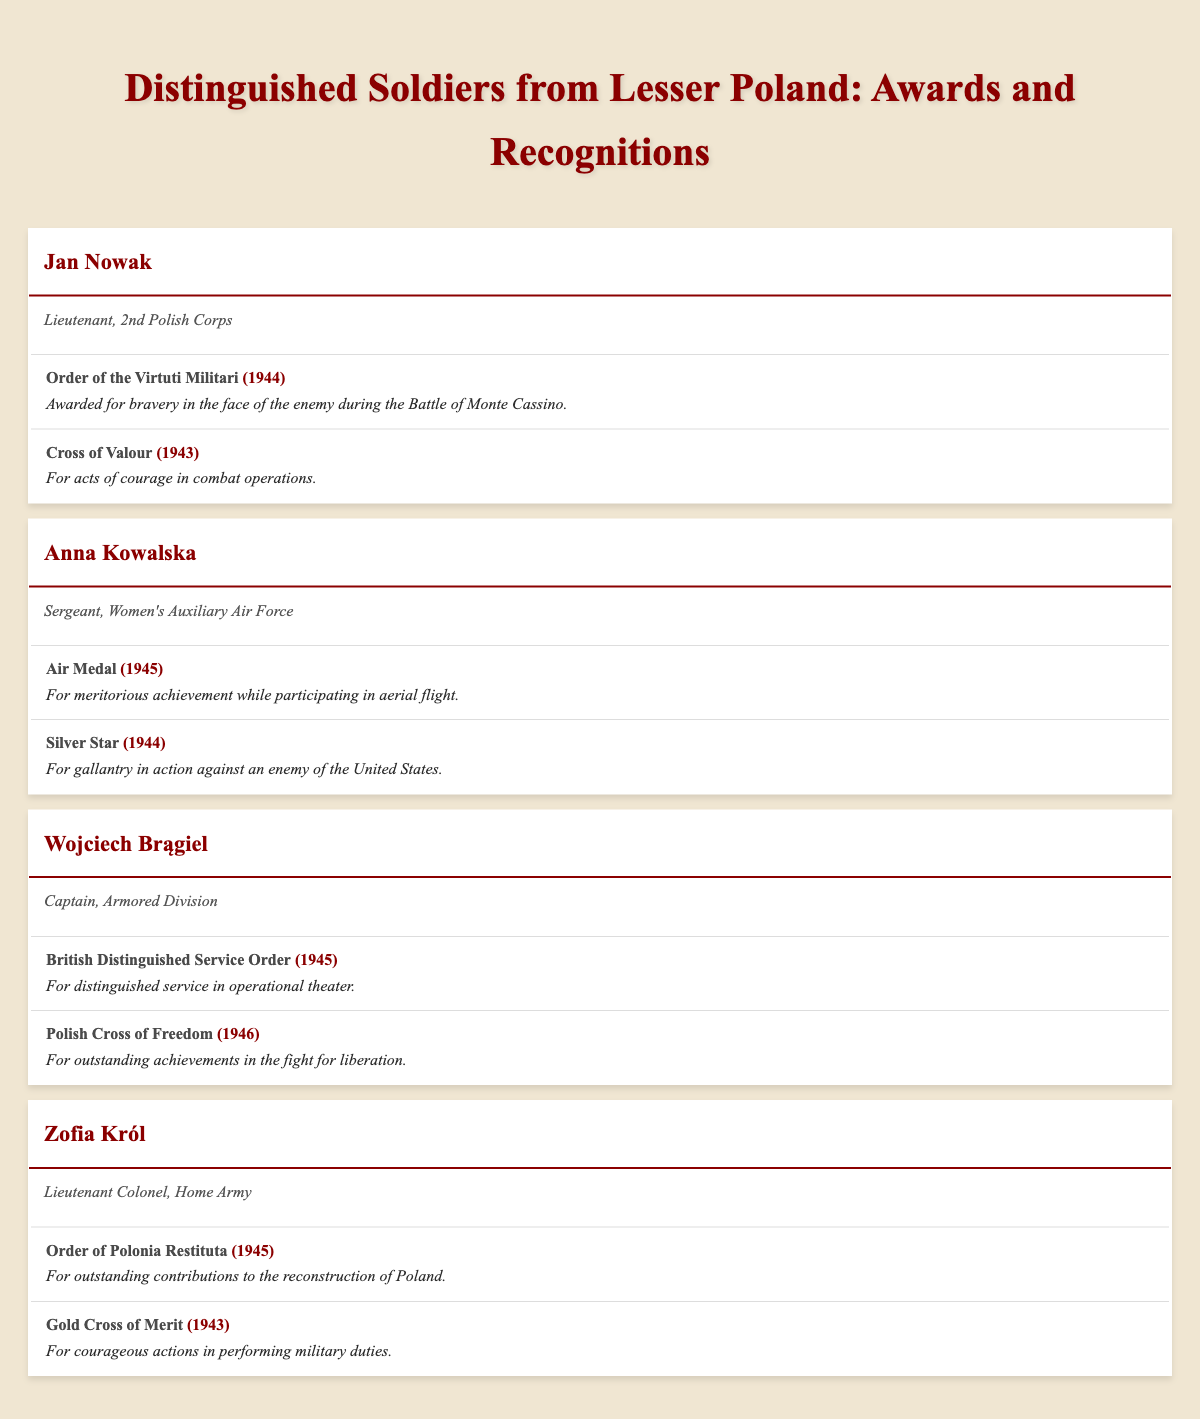What is the rank of Jan Nowak? Jan Nowak is listed in the table under the distinguished soldiers of Lesser Poland, with his rank noted as Lieutenant.
Answer: Lieutenant How many awards did Anna Kowalska receive? Looking at the entry for Anna Kowalska, it shows two awards: the Air Medal and the Silver Star, confirming that she received a total of two awards.
Answer: 2 Who received the Order of the Virtuti Militari? The table indicates that Jan Nowak received the Order of the Virtuti Militari in 1944, specifically for bravery during the Battle of Monte Cassino.
Answer: Jan Nowak Is Zofia Król part of the Home Army? The entry for Zofia Król shows that she served as a Lieutenant Colonel in the Home Army, confirming her association with that unit.
Answer: Yes Which award did Wojciech Brągiel receive in 1946? According to the table, Wojciech Brągiel received the Polish Cross of Freedom in 1946 for his outstanding achievements in the fight for liberation.
Answer: Polish Cross of Freedom What is the total number of awards for all distinguished soldiers listed? Adding the awards from each soldier: Jan Nowak has 2, Anna Kowalska has 2, Wojciech Brągiel has 2, and Zofia Król has 2, totaling 2 + 2 + 2 + 2 = 8 awards.
Answer: 8 Did any soldier receive an award for contributions to the reconstruction of Poland? Zofia Król received the Order of Polonia Restituta in 1945 for her outstanding contributions to the reconstruction of Poland, confirming that at least one soldier did receive such an award.
Answer: Yes What is the relationship between the year 1945 and the awards received? In the data, both Anna Kowalska and Wojciech Brągiel received awards in 1945, specifically the Air Medal and the British Distinguished Service Order, respectively. This indicates that 1945 is a notable year for these distinguished soldiers.
Answer: 2 awards received in 1945 How many awards does Zofia Król have compared to Jan Nowak? Both Zofia Król and Jan Nowak have received 2 awards each, so there is no difference in the number of awards they received.
Answer: They have the same number: 2 each 